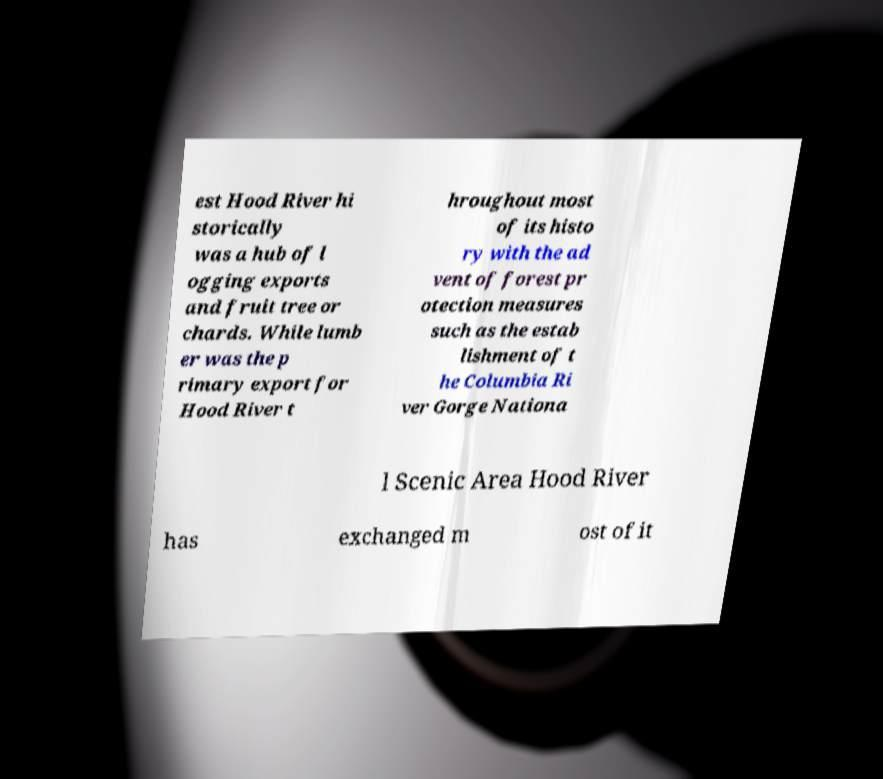Could you extract and type out the text from this image? est Hood River hi storically was a hub of l ogging exports and fruit tree or chards. While lumb er was the p rimary export for Hood River t hroughout most of its histo ry with the ad vent of forest pr otection measures such as the estab lishment of t he Columbia Ri ver Gorge Nationa l Scenic Area Hood River has exchanged m ost of it 